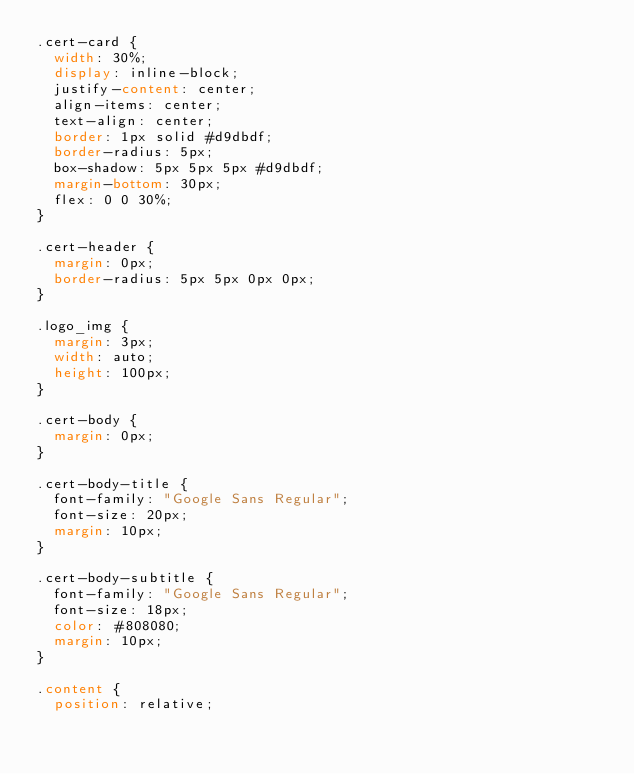Convert code to text. <code><loc_0><loc_0><loc_500><loc_500><_CSS_>.cert-card {
  width: 30%;
  display: inline-block;
  justify-content: center;
  align-items: center;
  text-align: center;
  border: 1px solid #d9dbdf;
  border-radius: 5px;
  box-shadow: 5px 5px 5px #d9dbdf;
  margin-bottom: 30px;
  flex: 0 0 30%;
}

.cert-header {
  margin: 0px;
  border-radius: 5px 5px 0px 0px;
}

.logo_img {
  margin: 3px;
  width: auto;
  height: 100px;
}

.cert-body {
  margin: 0px;
}

.cert-body-title {
  font-family: "Google Sans Regular";
  font-size: 20px;
  margin: 10px;
}

.cert-body-subtitle {
  font-family: "Google Sans Regular";
  font-size: 18px;
  color: #808080;
  margin: 10px;
}

.content {
  position: relative;</code> 